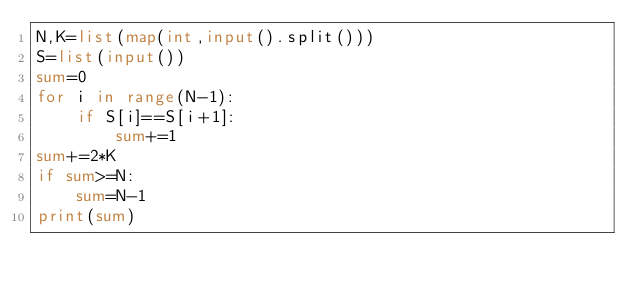<code> <loc_0><loc_0><loc_500><loc_500><_Python_>N,K=list(map(int,input().split()))
S=list(input())
sum=0
for i in range(N-1):
    if S[i]==S[i+1]:
        sum+=1
sum+=2*K
if sum>=N:
    sum=N-1
print(sum)</code> 